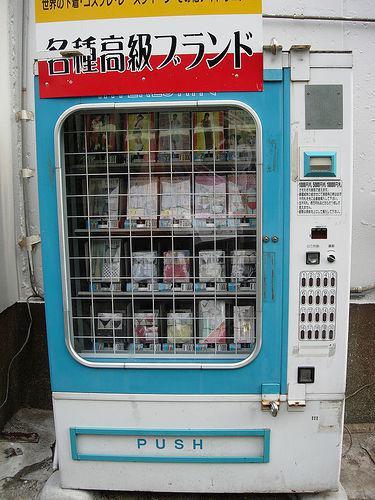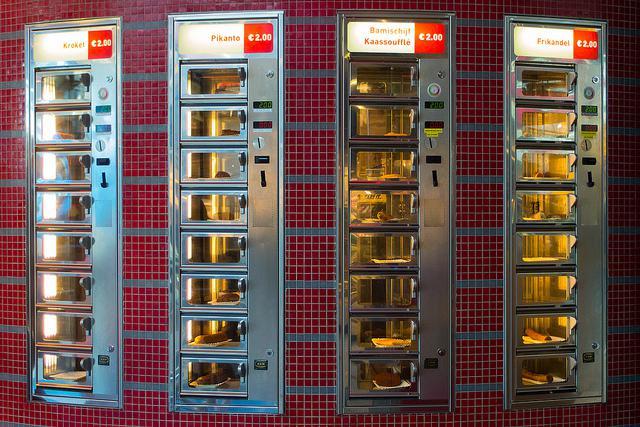The first image is the image on the left, the second image is the image on the right. Assess this claim about the two images: "The left image contains a single vending machine.". Correct or not? Answer yes or no. Yes. The first image is the image on the left, the second image is the image on the right. Considering the images on both sides, is "An image is focused on one vending machine, which features on its front large Asian characters on a field of red, yellow and blue stripes." valid? Answer yes or no. Yes. 